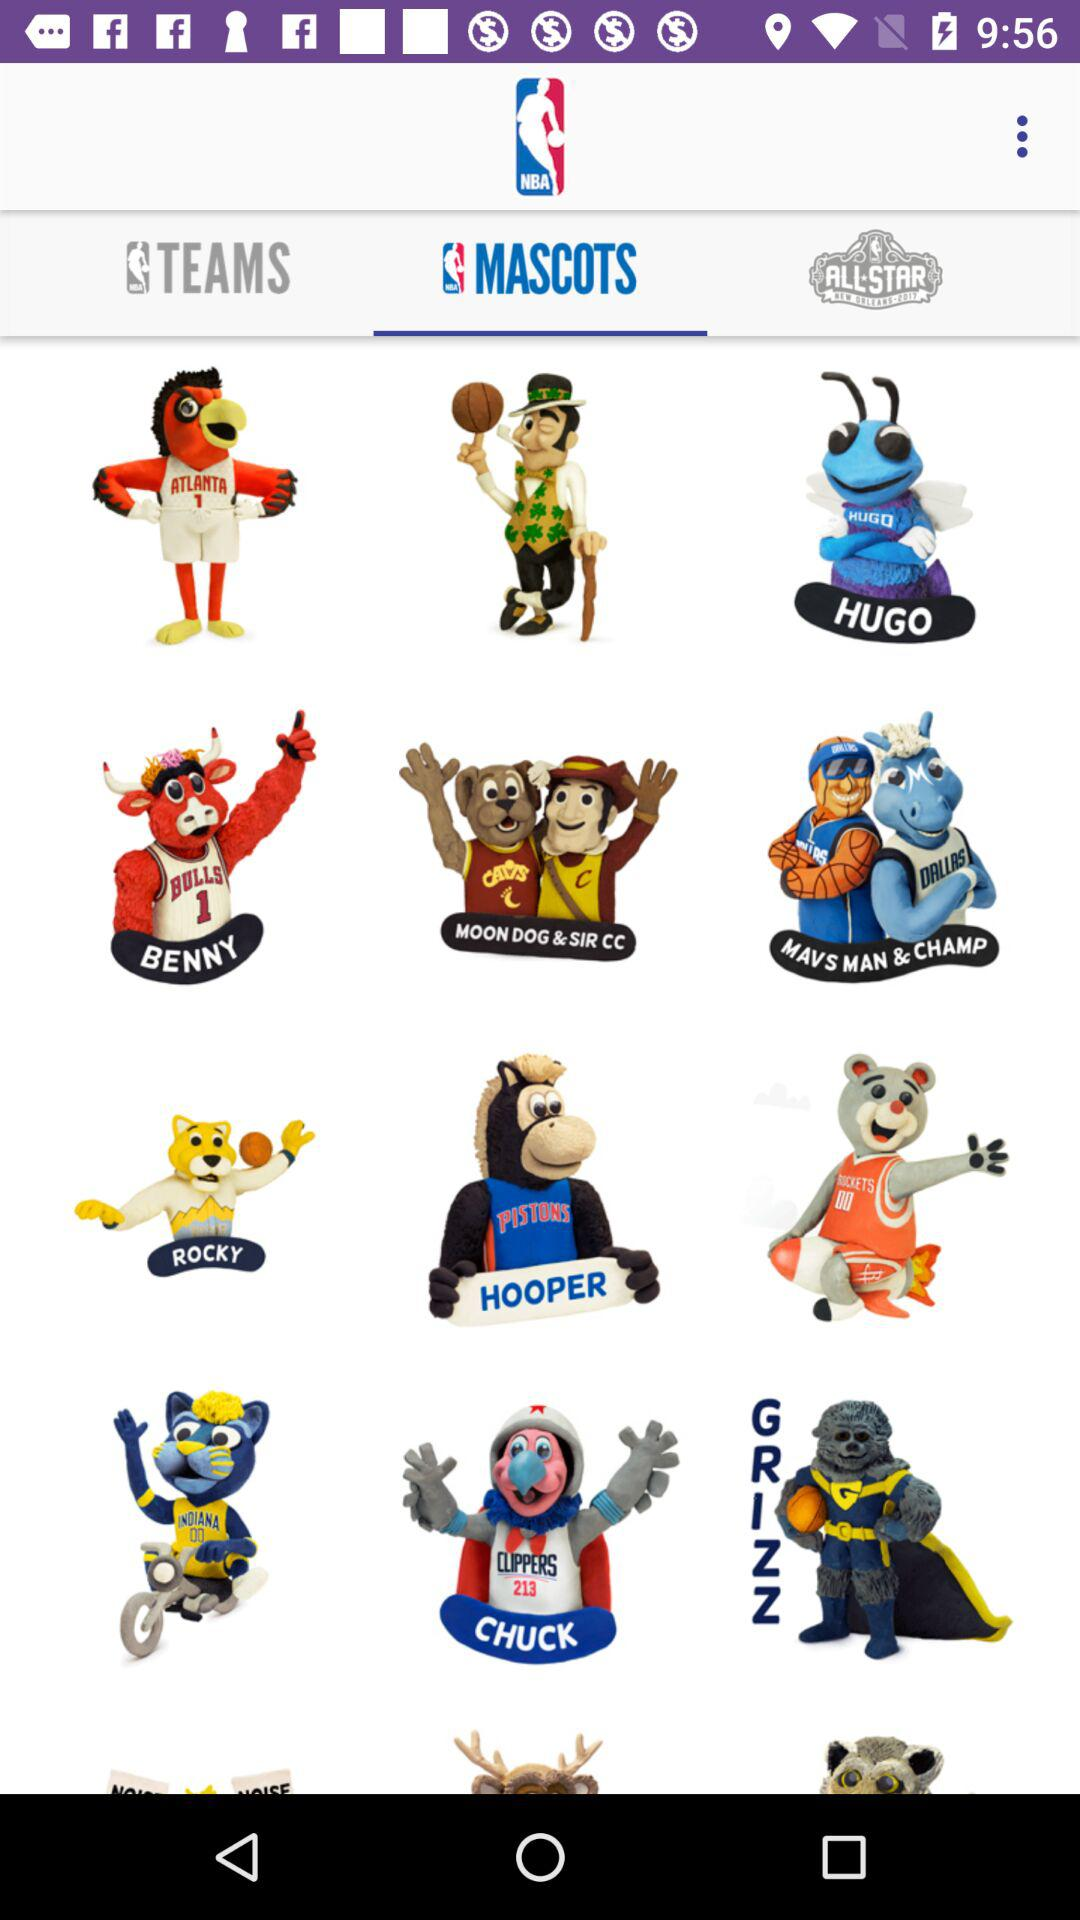Which tab has been selected? The tab "MASCOTS" has been selected. 